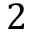Convert formula to latex. <formula><loc_0><loc_0><loc_500><loc_500>2</formula> 